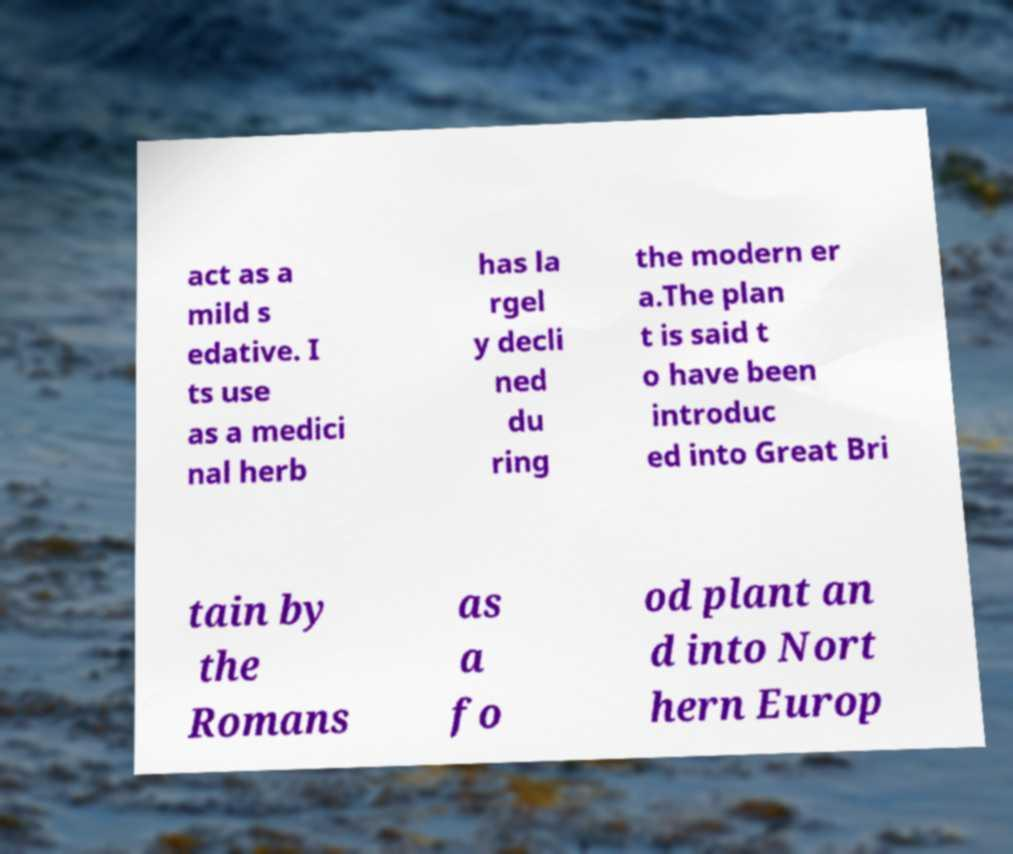Could you extract and type out the text from this image? act as a mild s edative. I ts use as a medici nal herb has la rgel y decli ned du ring the modern er a.The plan t is said t o have been introduc ed into Great Bri tain by the Romans as a fo od plant an d into Nort hern Europ 